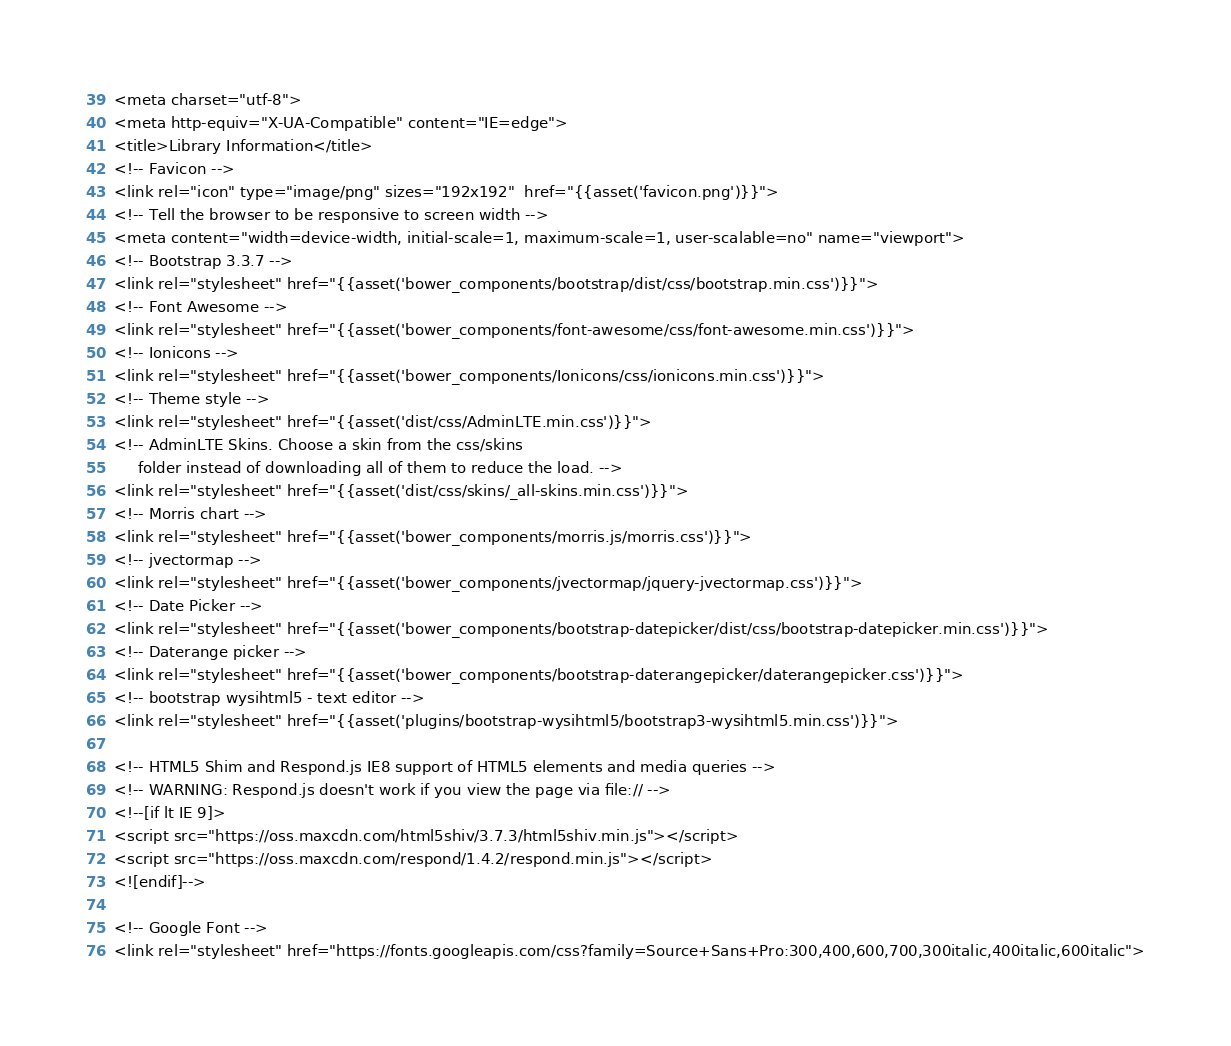<code> <loc_0><loc_0><loc_500><loc_500><_PHP_><meta charset="utf-8">
<meta http-equiv="X-UA-Compatible" content="IE=edge">
<title>Library Information</title>
<!-- Favicon -->
<link rel="icon" type="image/png" sizes="192x192"  href="{{asset('favicon.png')}}">
<!-- Tell the browser to be responsive to screen width -->
<meta content="width=device-width, initial-scale=1, maximum-scale=1, user-scalable=no" name="viewport">
<!-- Bootstrap 3.3.7 -->
<link rel="stylesheet" href="{{asset('bower_components/bootstrap/dist/css/bootstrap.min.css')}}">
<!-- Font Awesome -->
<link rel="stylesheet" href="{{asset('bower_components/font-awesome/css/font-awesome.min.css')}}">
<!-- Ionicons -->
<link rel="stylesheet" href="{{asset('bower_components/Ionicons/css/ionicons.min.css')}}">
<!-- Theme style -->
<link rel="stylesheet" href="{{asset('dist/css/AdminLTE.min.css')}}">
<!-- AdminLTE Skins. Choose a skin from the css/skins
     folder instead of downloading all of them to reduce the load. -->
<link rel="stylesheet" href="{{asset('dist/css/skins/_all-skins.min.css')}}">
<!-- Morris chart -->
<link rel="stylesheet" href="{{asset('bower_components/morris.js/morris.css')}}">
<!-- jvectormap -->
<link rel="stylesheet" href="{{asset('bower_components/jvectormap/jquery-jvectormap.css')}}">
<!-- Date Picker -->
<link rel="stylesheet" href="{{asset('bower_components/bootstrap-datepicker/dist/css/bootstrap-datepicker.min.css')}}">
<!-- Daterange picker -->
<link rel="stylesheet" href="{{asset('bower_components/bootstrap-daterangepicker/daterangepicker.css')}}">
<!-- bootstrap wysihtml5 - text editor -->
<link rel="stylesheet" href="{{asset('plugins/bootstrap-wysihtml5/bootstrap3-wysihtml5.min.css')}}">

<!-- HTML5 Shim and Respond.js IE8 support of HTML5 elements and media queries -->
<!-- WARNING: Respond.js doesn't work if you view the page via file:// -->
<!--[if lt IE 9]>
<script src="https://oss.maxcdn.com/html5shiv/3.7.3/html5shiv.min.js"></script>
<script src="https://oss.maxcdn.com/respond/1.4.2/respond.min.js"></script>
<![endif]-->

<!-- Google Font -->
<link rel="stylesheet" href="https://fonts.googleapis.com/css?family=Source+Sans+Pro:300,400,600,700,300italic,400italic,600italic"></code> 